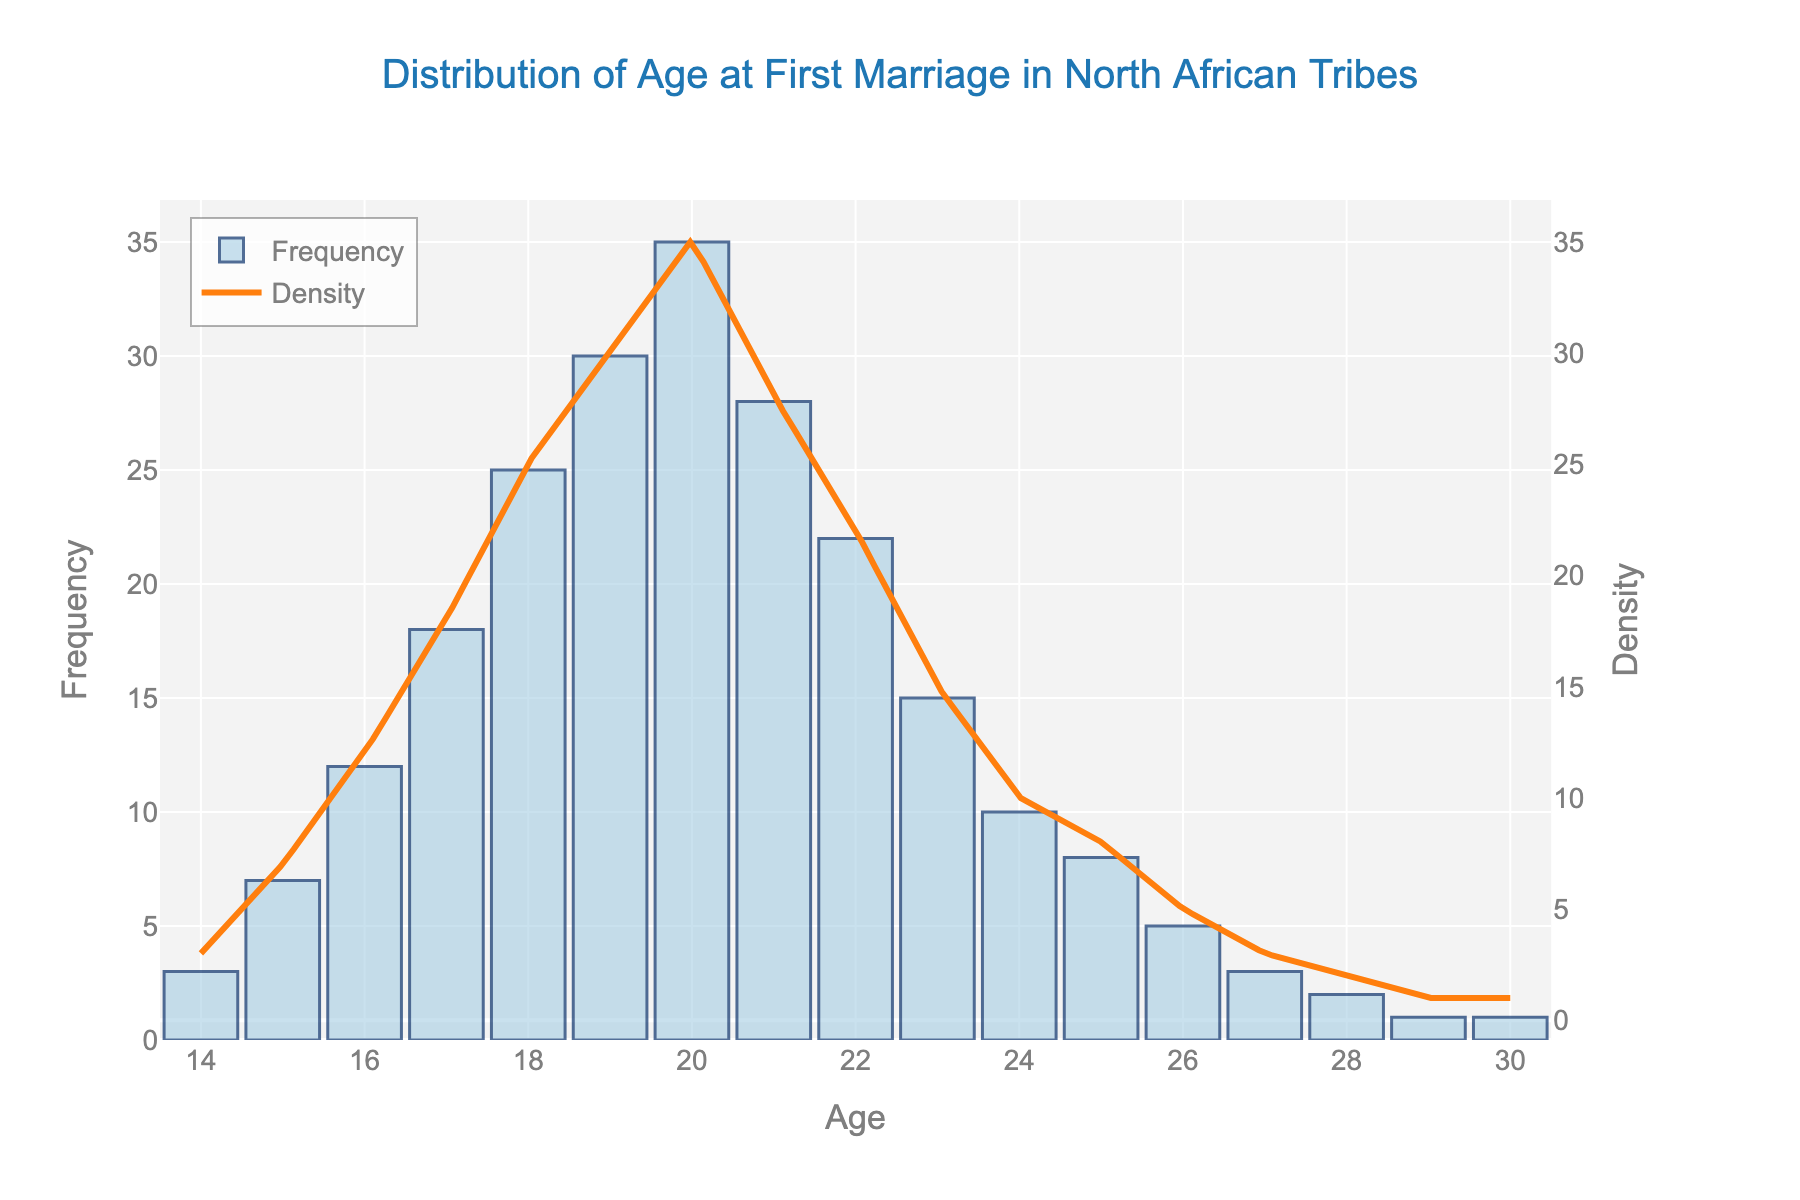What's the title of the histogram with KDE plot? The figure has a title displayed at the top which reads "Distribution of Age at First Marriage in North African Tribes".
Answer: Distribution of Age at First Marriage in North African Tribes What is the most frequent age at first marriage? The histogram shows that the tallest bar, indicating the highest frequency, corresponds to the age of 20.
Answer: 20 Which age has the lowest frequency of first marriages? By observing the histogram, the bars for ages 29 and 30 are the shortest, indicating the lowest frequency.
Answer: 29 and 30 How many age groups have a frequency higher than 20? By counting the bars in the histogram that exceed the frequency of 20, we notice that ages 18, 19, 20, and 21 each have a frequency higher than 20.
Answer: 4 What's the age range displayed on the x-axis? The x-axis of the histogram spans from age 14 to age 30.
Answer: 14 to 30 At what age does the KDE density curve reach its peak? The KDE curve reaches its peak at the same age where the histogram shows the highest frequency, which occurs at age 20.
Answer: 20 What's the total number of marriages occurring at ages 18 and 19 combined? The frequencies at ages 18 and 19 combined are 25 + 30, which totals to 55.
Answer: 55 How does the frequency of marriages at age 22 compare to age 24? The frequency at age 22 is 22, whereas at age 24 it is 10. Therefore, age 22 has a higher frequency compared to age 24.
Answer: Age 22 is higher What's the difference in frequency between the highest and the lowest ages? The highest frequency is at age 20 with 35 marriages, and the lowest frequencies are at ages 29 and 30, each with 1 marriage. The difference is 35 - 1.
Answer: 34 Describe the overall trend in the distribution of age at first marriage. The histogram indicates an increasing trend in frequencies from ages 14 to 20, peaking at age 20, then gradually decreasing in frequency after age 20.
Answer: Increase then decrease 